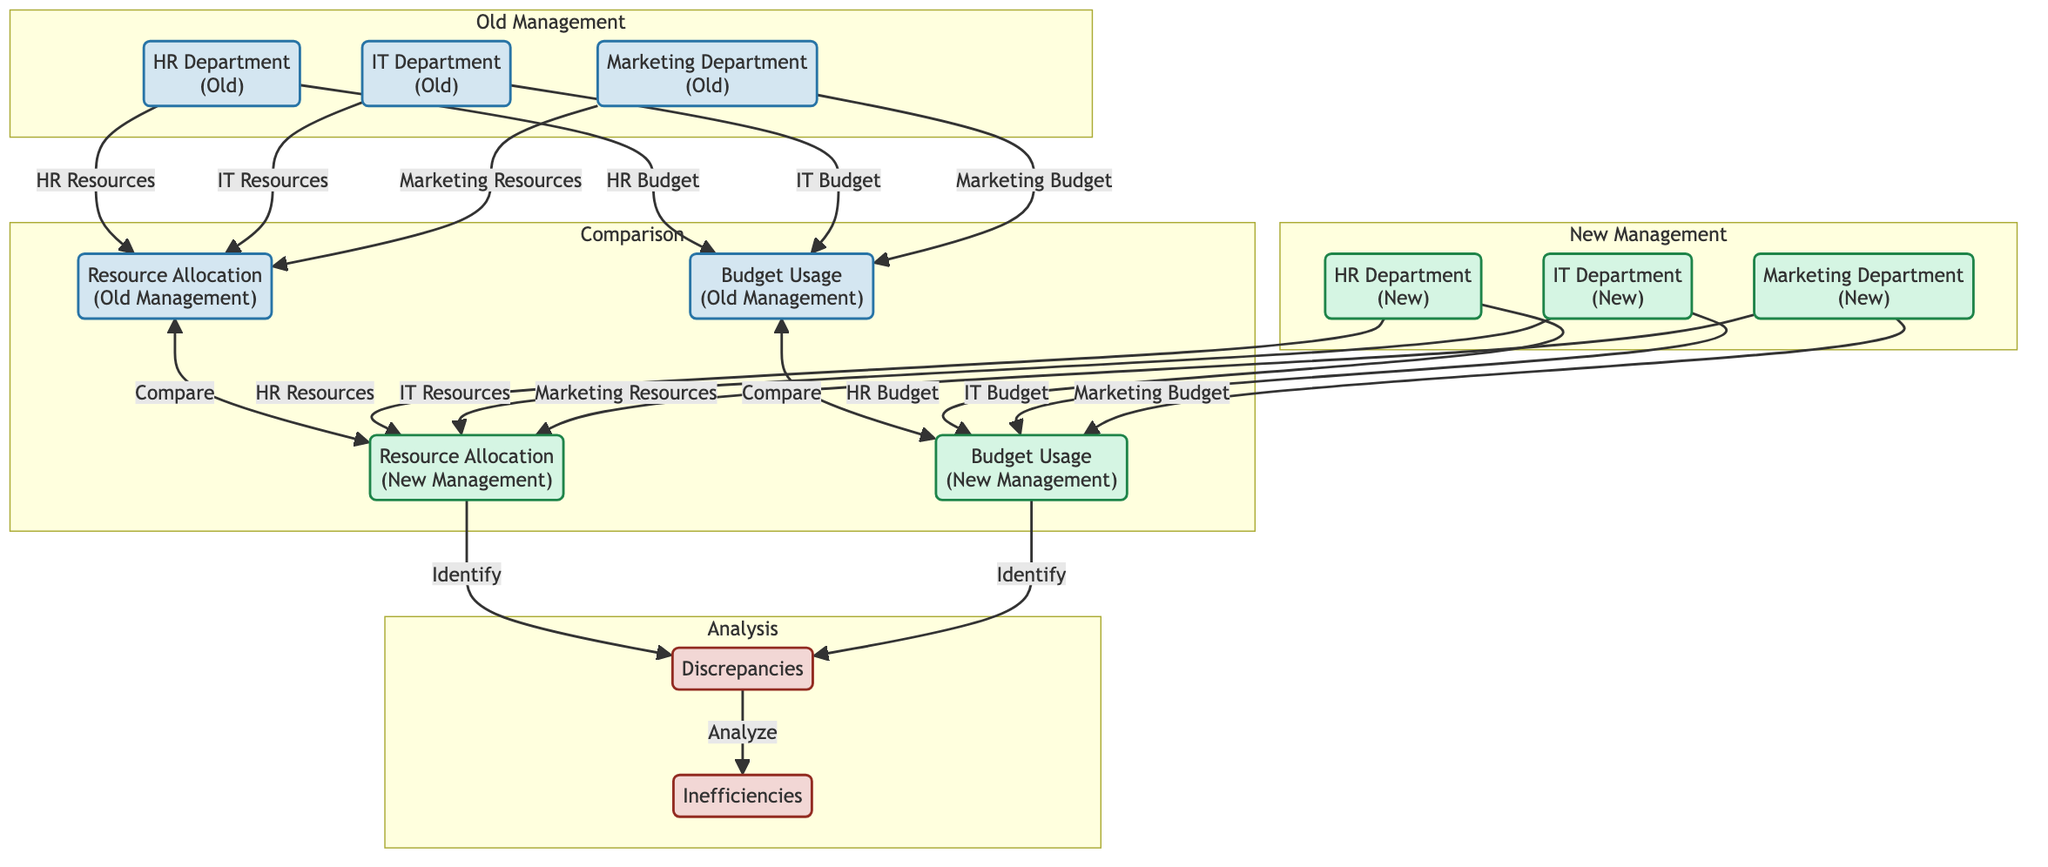What is the color associated with the HR Department under old management? In the diagram, the HR Department under old management is shown within a node that uses the class definition labeled as `oldNode`, which has a fill color of light blue (#d4e6f1).
Answer: Light blue How many departments are compared in the diagram? The diagram includes three departments: HR, IT, and Marketing, which are shown under both old management and new management. Thus, adding both segments gives a total of six departments to compare.
Answer: Six What is the connection type between "resources_old" and "resources_new"? The connection type between "resources_old" and "resources_new" is labeled as "Compare," indicating the purpose of their relationship as a comparative analysis of resource allocation.
Answer: Compare Which department shows changes in resource allocation between old and new management? All three departments (HR, IT, Marketing) display changes in resource allocation between old and new management as they are linked to both resource nodes, indicating a comparison of their resources.
Answer: HR, IT, Marketing What do the "Discrepancies" and "Inefficiencies" nodes represent? The nodes "Discrepancies" and "Inefficiencies" are part of the analysis subgraph, indicating they represent findings from comparing both resource allocations and budget usages under both management styles, with discrepancies identified leading to further analysis of inefficiencies.
Answer: Findings from analysis How many budget nodes are there for old management? The diagram has three budget nodes corresponding to the three departments (HR, IT, Marketing) under old management; thus, there are a total of three budget nodes in that section.
Answer: Three Which node identifies inefficiencies after analyzing discrepancies? The node that follows the analysis of discrepancies to identify inefficiencies is directly labeled as "Inefficiencies," represented as a result from the analysis steps involving discrepancies.
Answer: Inefficiencies What type of analysis is performed between "budget_old" and "budget_new"? The analysis performed between "budget_old" and "budget_new" is labeled as "Identify," indicating that the purpose of this comparison is to point out the differences or gaps in budget utilization between the two management styles.
Answer: Identify 